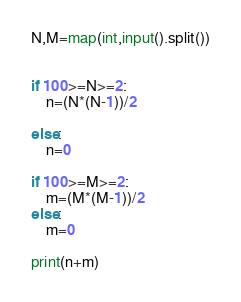<code> <loc_0><loc_0><loc_500><loc_500><_Python_>N,M=map(int,input().split())


if 100>=N>=2:
    n=(N*(N-1))/2

else:
    n=0

if 100>=M>=2:
    m=(M*(M-1))/2
else:
    m=0
    
print(n+m)</code> 